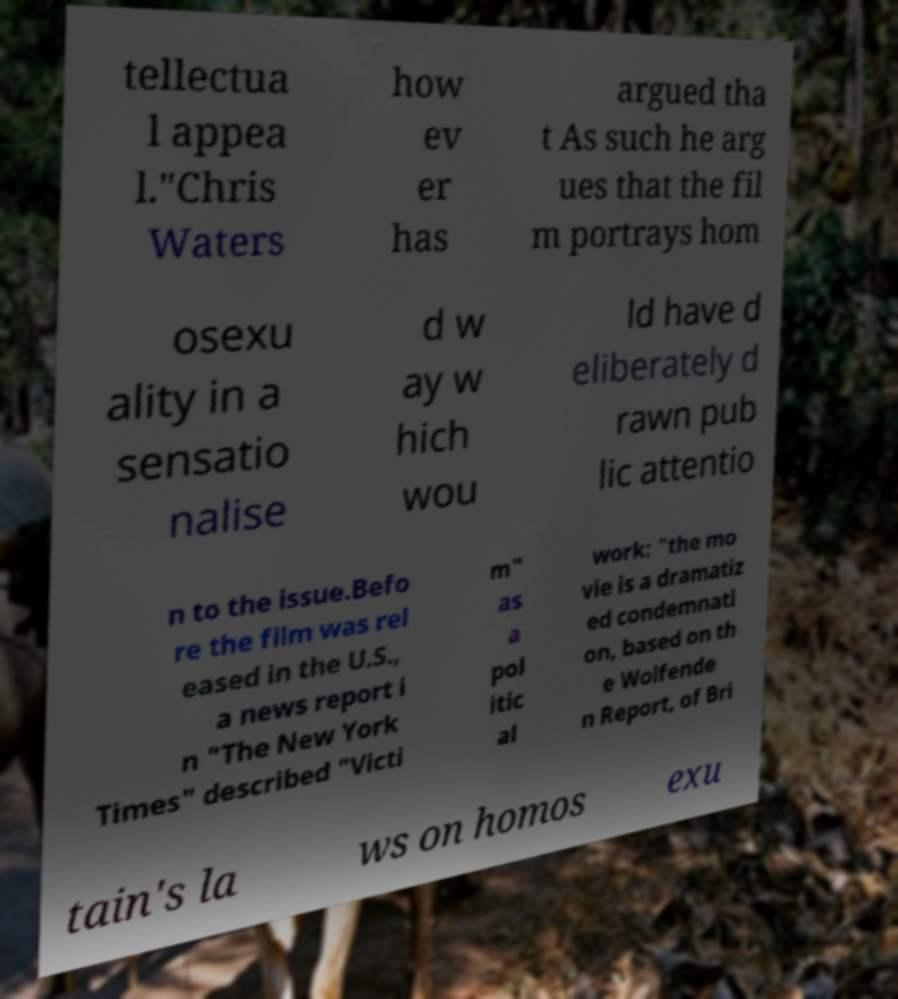Please read and relay the text visible in this image. What does it say? tellectua l appea l."Chris Waters how ev er has argued tha t As such he arg ues that the fil m portrays hom osexu ality in a sensatio nalise d w ay w hich wou ld have d eliberately d rawn pub lic attentio n to the issue.Befo re the film was rel eased in the U.S., a news report i n "The New York Times" described "Victi m" as a pol itic al work: "the mo vie is a dramatiz ed condemnati on, based on th e Wolfende n Report, of Bri tain's la ws on homos exu 